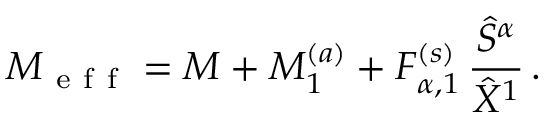Convert formula to latex. <formula><loc_0><loc_0><loc_500><loc_500>M _ { e f f } = M + M _ { 1 } ^ { ( a ) } + F _ { \alpha , 1 } ^ { ( s ) } \, \frac { \hat { S } ^ { \alpha } } { \hat { X } ^ { 1 } } \, .</formula> 